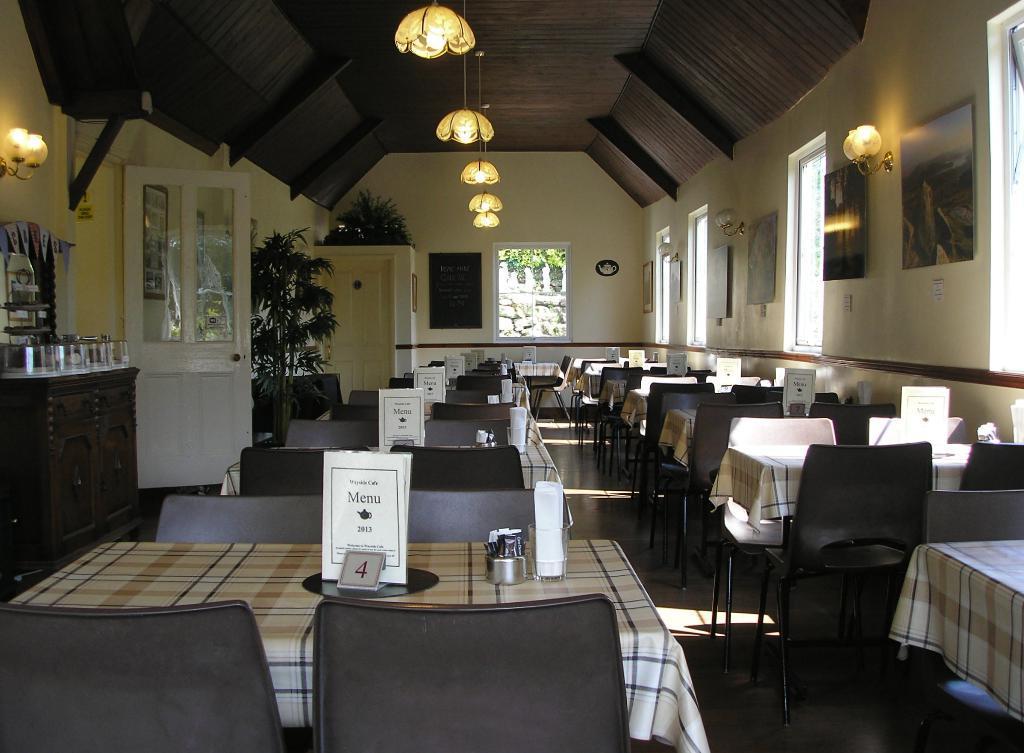Could you give a brief overview of what you see in this image? In this picture I can see tables, chairs, cards, boards, there are lights, house plants, there are frames attached to the wall and there are some objects. 